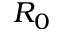<formula> <loc_0><loc_0><loc_500><loc_500>R _ { 0 }</formula> 